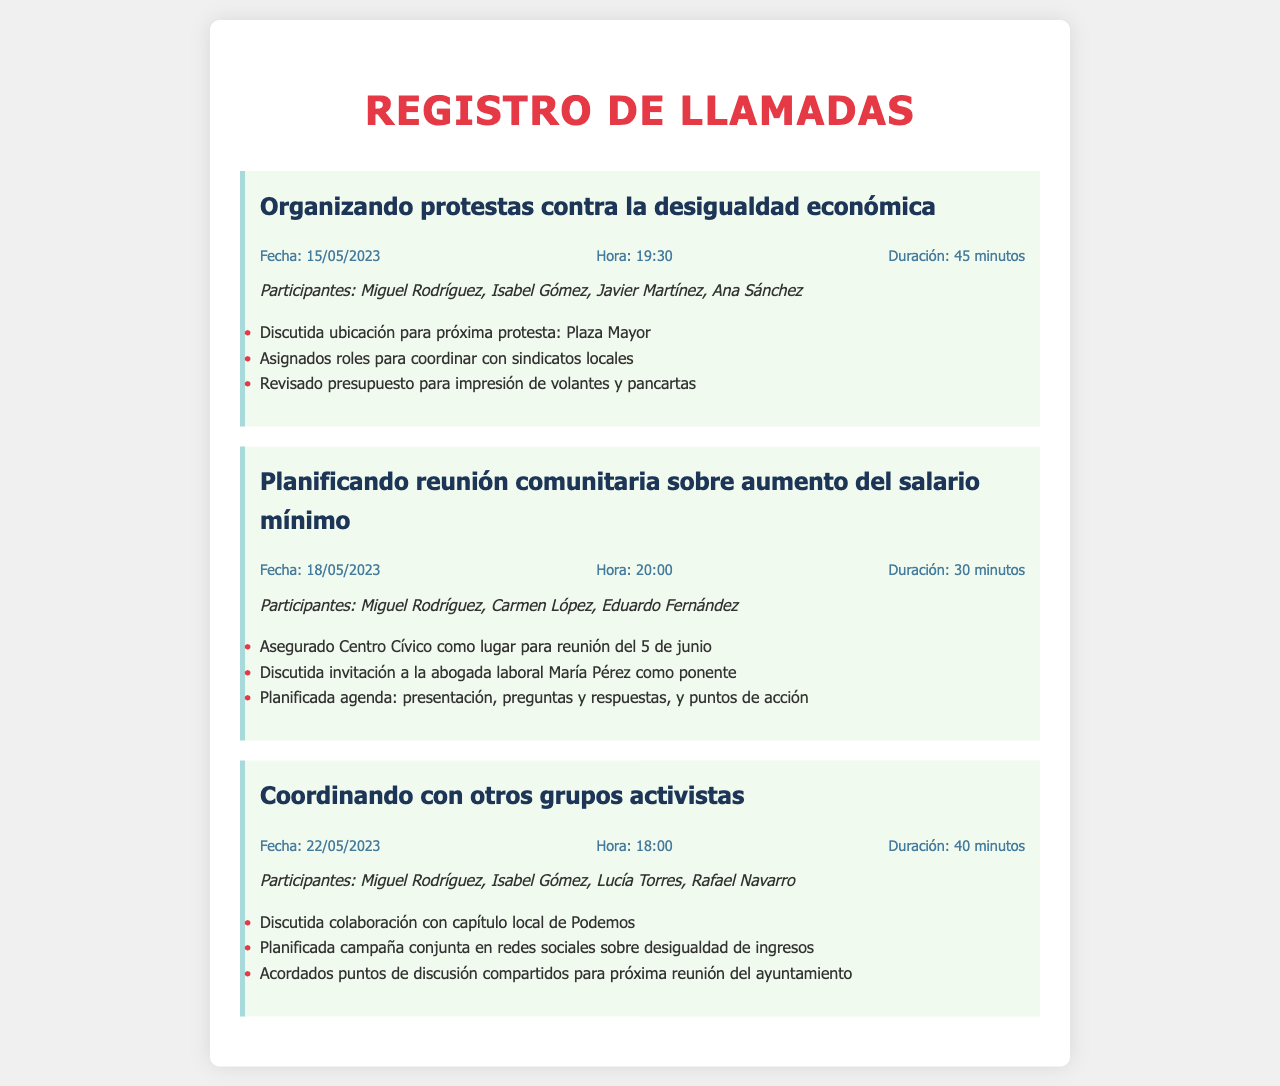¿Qué tema se discutió en la primera llamada? La primera llamada se centró en la organización de protestas contra la desigualdad económica.
Answer: Protestas contra la desigualdad económica ¿Cuál fue la fecha de la segunda llamada? La segunda llamada se realizó el 18 de mayo de 2023.
Answer: 18/05/2023 ¿Cuántos minutos duró la llamada sobre la coordinación con otros grupos activistas? La llamada coordinando con otros grupos activistas tuvo una duración de 40 minutos.
Answer: 40 minutos ¿Quién fue uno de los participantes en la reunión sobre el aumento del salario mínimo? Uno de los participantes en la reunión fue Carmen López.
Answer: Carmen López ¿Cuál fue el lugar asegurado para la reunión del 5 de junio? Se aseguró el Centro Cívico como lugar para la reunión del 5 de junio.
Answer: Centro Cívico ¿Qué se planificó en la llamada del 22 de mayo? Se planificó una campaña conjunta en redes sociales sobre desigualdad de ingresos.
Answer: Campaña conjunta en redes sociales ¿Cómo se definieron las tareas en la primera llamada? Se asignaron roles para coordinar con sindicatos locales.
Answer: Roles para coordinar con sindicatos locales ¿Quién fue mencionado como ponente en la reunión sobre salario mínimo? Se discutió la invitación a la abogada laboral María Pérez como ponente.
Answer: María Pérez ¿Qué se revisó en la llamada sobre protestas? Se revisó el presupuesto para impresión de volantes y pancartas.
Answer: Presupuesto para impresión de volantes y pancartas 